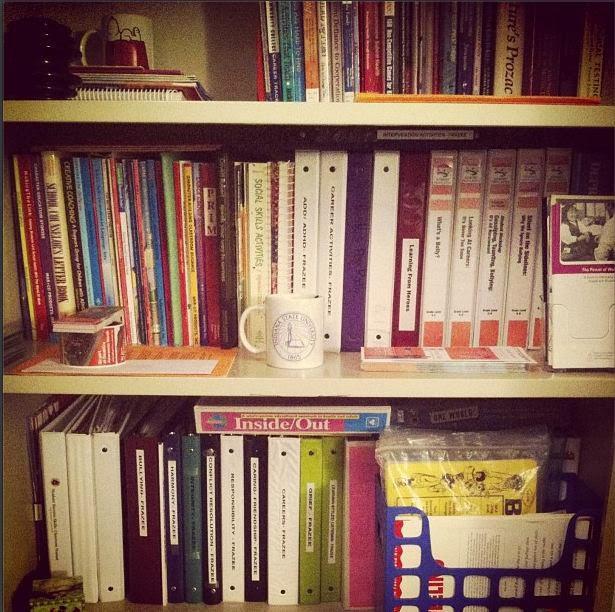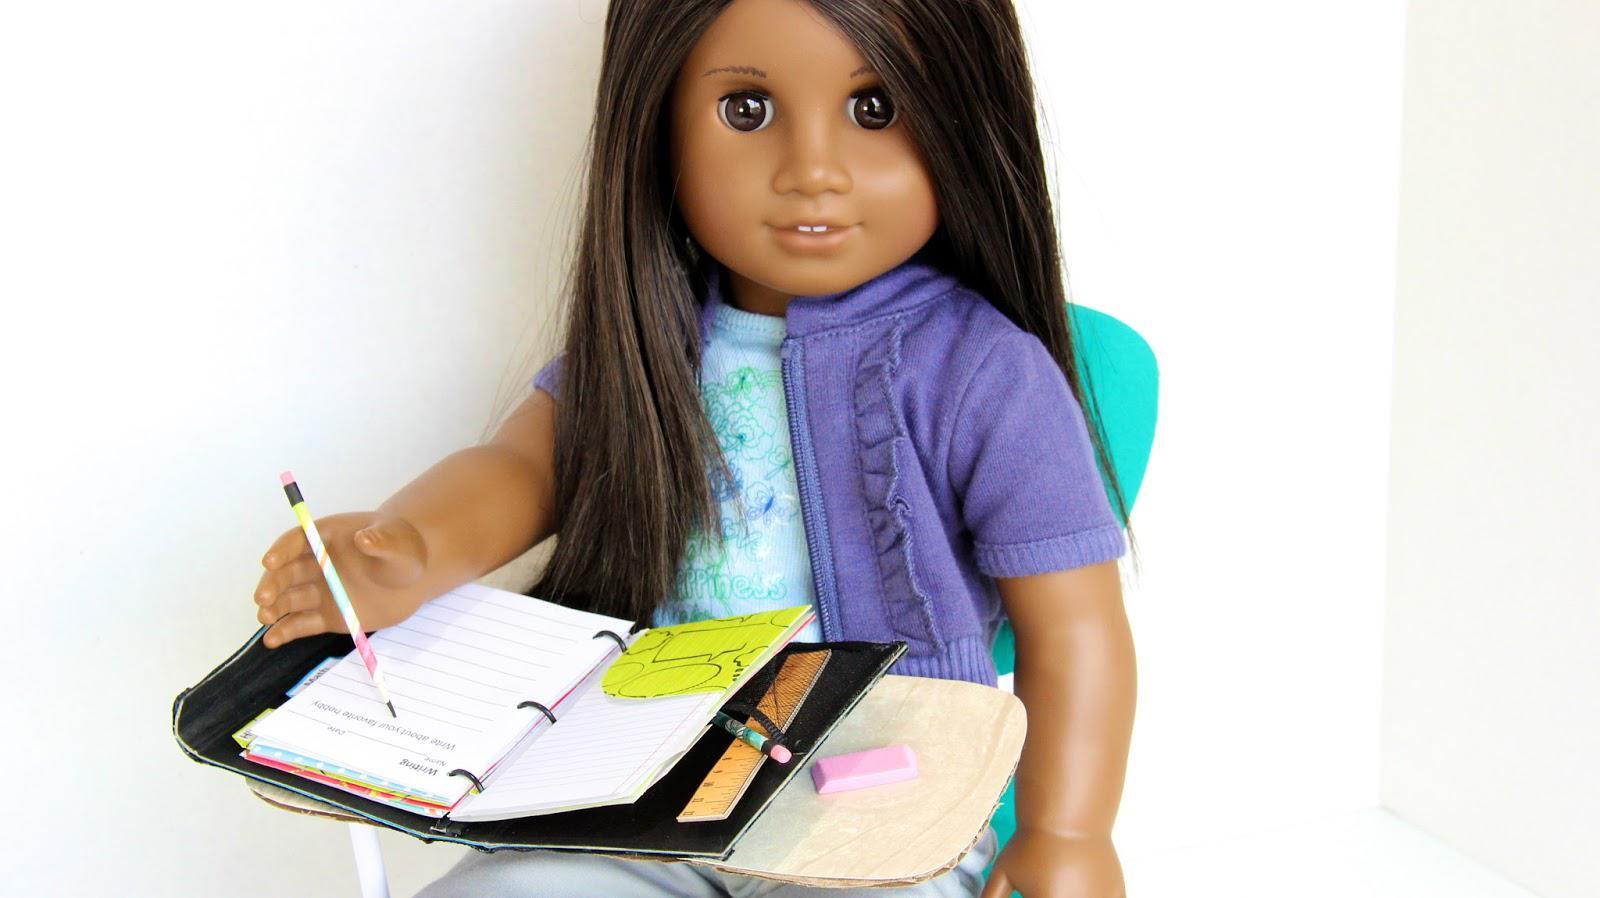The first image is the image on the left, the second image is the image on the right. Considering the images on both sides, is "A woman holds a pile of binders." valid? Answer yes or no. No. The first image is the image on the left, the second image is the image on the right. Assess this claim about the two images: "A person's arms wrap around a bunch of binders in one image.". Correct or not? Answer yes or no. No. 